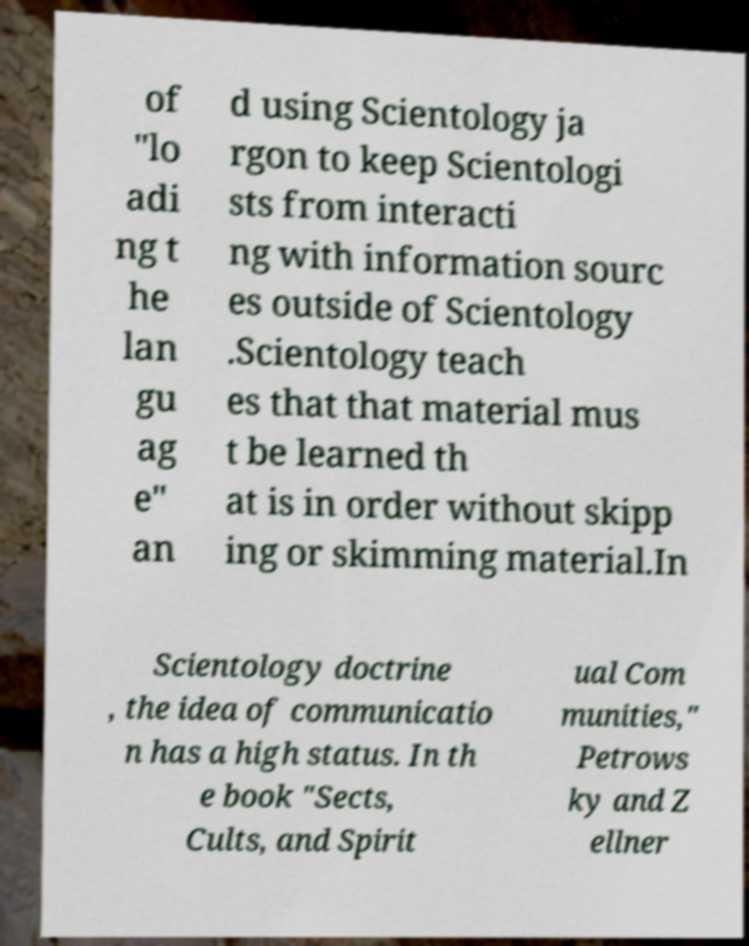Can you accurately transcribe the text from the provided image for me? of "lo adi ng t he lan gu ag e" an d using Scientology ja rgon to keep Scientologi sts from interacti ng with information sourc es outside of Scientology .Scientology teach es that that material mus t be learned th at is in order without skipp ing or skimming material.In Scientology doctrine , the idea of communicatio n has a high status. In th e book "Sects, Cults, and Spirit ual Com munities," Petrows ky and Z ellner 